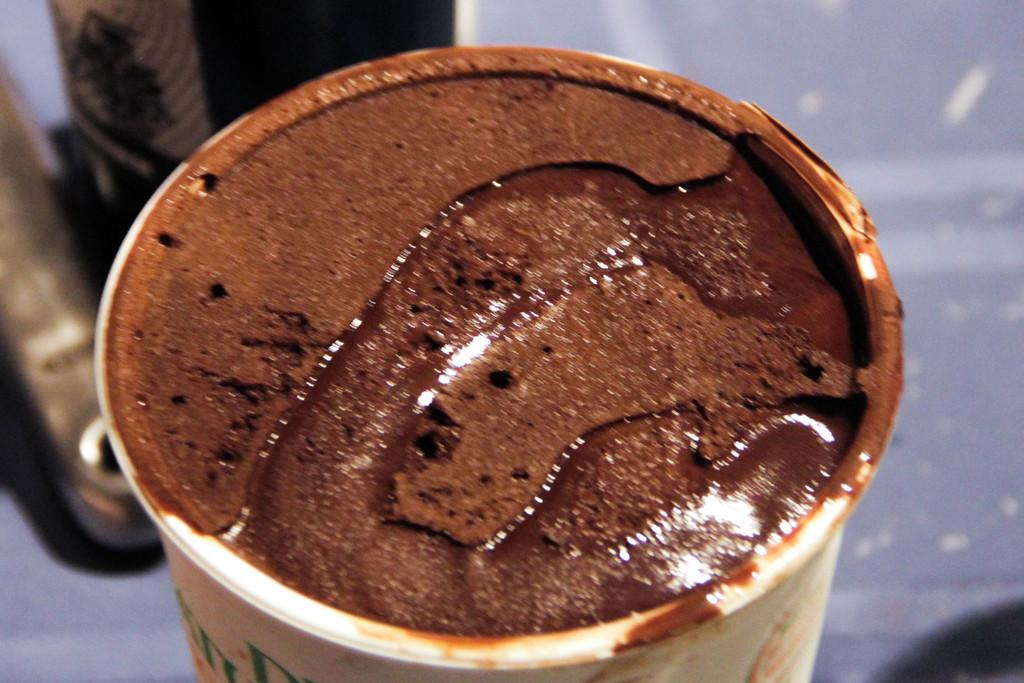What is in the cup that is visible in the image? There is a cup in the image, and it appears to contain a liquid. Can you describe the contents of the liquid in the cup? Yes, there is chocolate paste visible in the cup. What else can be seen in the image besides the cup and its contents? There are objects visible in the background of the image. Is the lawyer in the image discussing a case with the fan? There is no lawyer or fan present in the image; it only features a cup with chocolate paste and objects in the background. 